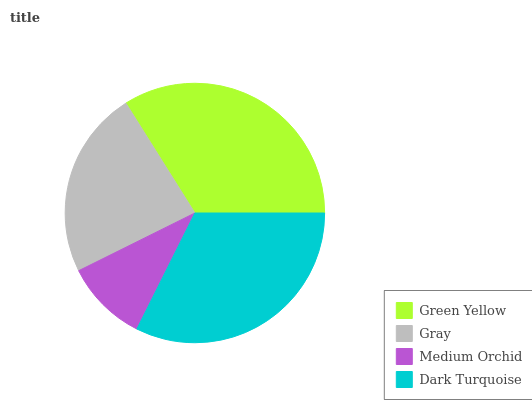Is Medium Orchid the minimum?
Answer yes or no. Yes. Is Green Yellow the maximum?
Answer yes or no. Yes. Is Gray the minimum?
Answer yes or no. No. Is Gray the maximum?
Answer yes or no. No. Is Green Yellow greater than Gray?
Answer yes or no. Yes. Is Gray less than Green Yellow?
Answer yes or no. Yes. Is Gray greater than Green Yellow?
Answer yes or no. No. Is Green Yellow less than Gray?
Answer yes or no. No. Is Dark Turquoise the high median?
Answer yes or no. Yes. Is Gray the low median?
Answer yes or no. Yes. Is Green Yellow the high median?
Answer yes or no. No. Is Green Yellow the low median?
Answer yes or no. No. 